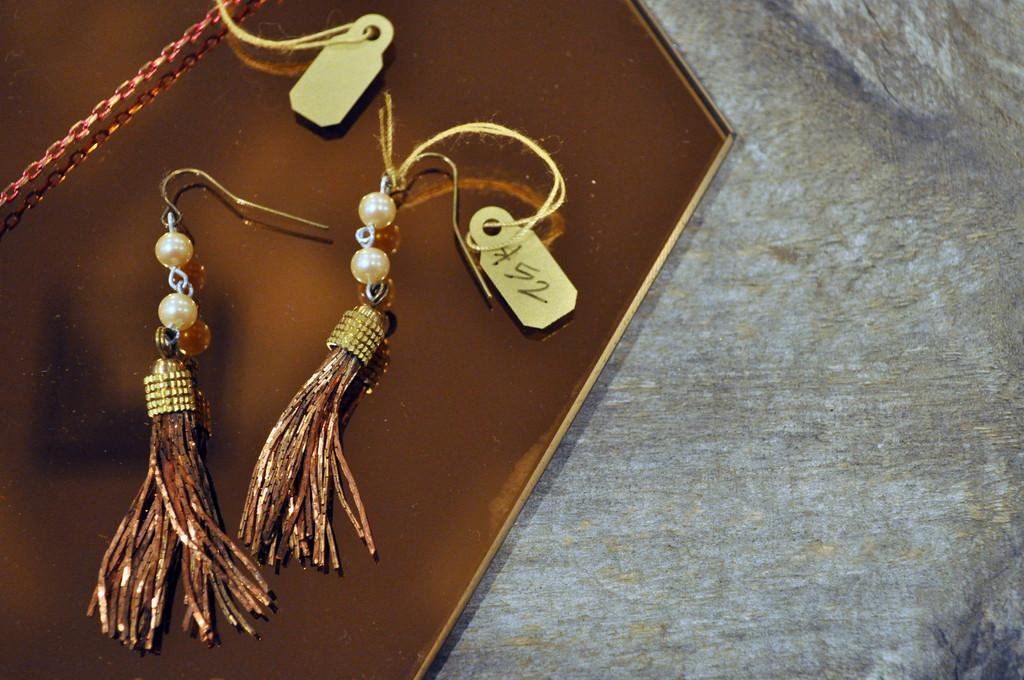What type of jewelry is on the brown color board? There are earrings on the brown color board. What additional information can be seen on the board? There are tags visible on the board. What is the color of the surface the board is placed on? The board is on a grey surface. What type of hope can be seen in the image? There is no reference to hope in the image; it features earrings on a brown color board with tags and a grey surface. 